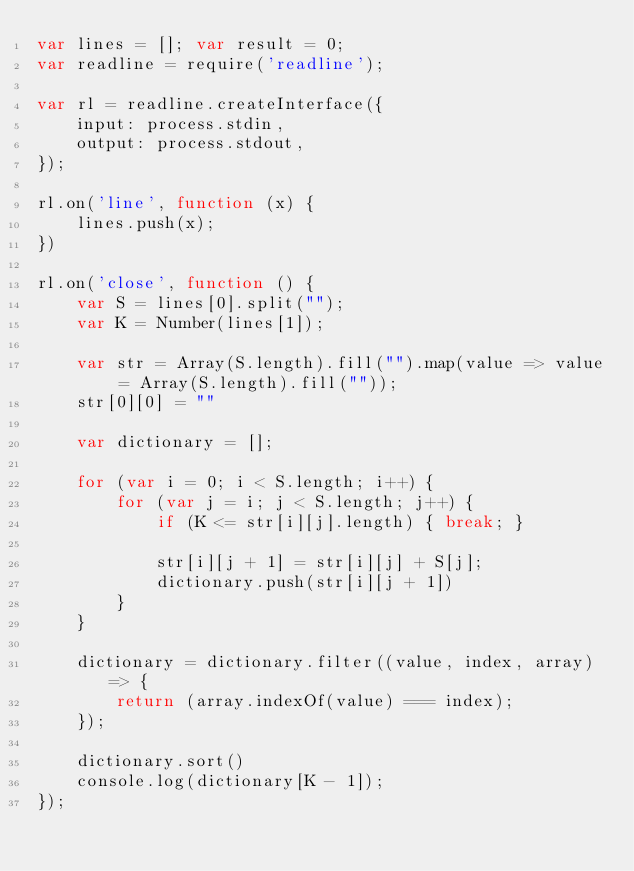Convert code to text. <code><loc_0><loc_0><loc_500><loc_500><_JavaScript_>var lines = []; var result = 0;
var readline = require('readline');

var rl = readline.createInterface({
    input: process.stdin,
    output: process.stdout,
});

rl.on('line', function (x) {
    lines.push(x);
})

rl.on('close', function () {
    var S = lines[0].split("");
    var K = Number(lines[1]);

    var str = Array(S.length).fill("").map(value => value = Array(S.length).fill(""));
    str[0][0] = ""

    var dictionary = [];

    for (var i = 0; i < S.length; i++) {
        for (var j = i; j < S.length; j++) {
            if (K <= str[i][j].length) { break; }

            str[i][j + 1] = str[i][j] + S[j];
            dictionary.push(str[i][j + 1])
        }
    }

    dictionary = dictionary.filter((value, index, array) => {
        return (array.indexOf(value) === index);
    });

    dictionary.sort()
    console.log(dictionary[K - 1]);
});
</code> 